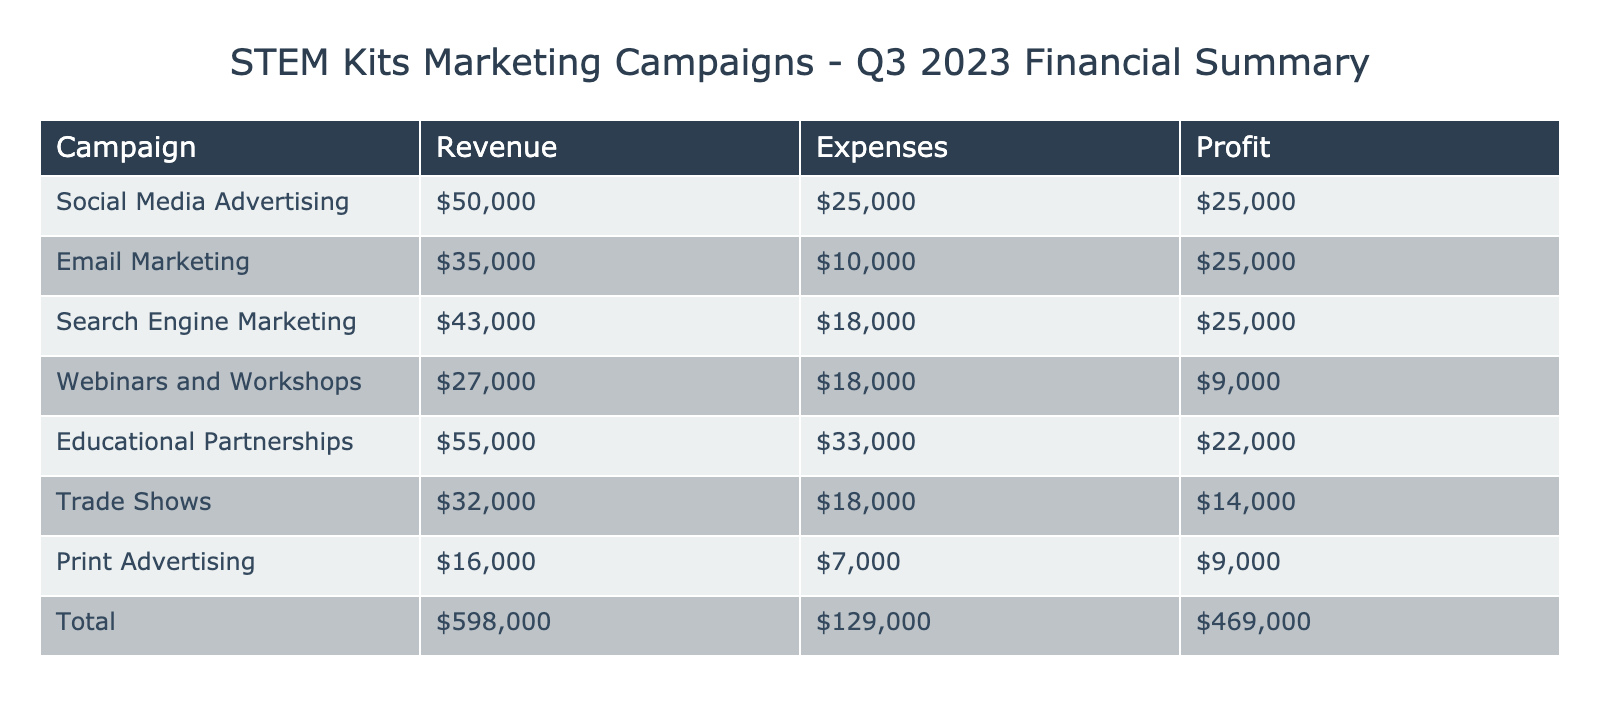What is the total revenue from all campaigns? To find the total revenue, sum the revenue amounts from each campaign: 50000 (Social Media) + 35000 (Email Marketing) + 43000 (Search Engine) + 27000 (Webinars) + 55000 (Partnerships) + 32000 (Trade Shows) + 16000 (Print) = 227000.
Answer: 227000 Which campaign had the highest profit? To determine the campaign with the highest profit, we calculate the profit for each campaign by subtracting total expenses from total revenue. The campaign with the highest profit is Educational Partnerships: 55000 (revenue) - 33000 (expenses) = 22000.
Answer: Educational Partnerships What is the total amount spent on Social Media Advertising? The total amount spent on Social Media Advertising is the sum of all expenses related to that campaign: 12000 (Facebook) + 8000 (Instagram) + 5000 (Twitter) = 25000.
Answer: 25000 Did Trade Shows have a higher expense than Search Engine Marketing? For Trade Shows, the total expense is 9000 (Booth) + 6000 (Travel) + 3000 (Marketing) = 18000. For Search Engine Marketing, the total expense is 15000 (Google) + 3000 (Bing) = 18000. Since the expenses are equal, the answer is no.
Answer: No What is the profit difference between Webinars and Workshops and Print Advertising? Calculate the profit of each campaign: Webinars has a revenue of 27000 and expenses of 18000, so profit is 9000. Print Advertising has a revenue of 16000 and expenses of 7000, so profit is 9000. The profit difference is 9000 - 9000 = 0.
Answer: 0 How much is spent on Email Marketing in total? The total amount spent on Email Marketing can be calculated by adding design and distribution costs: 4000 (Design) + 6000 (Distribution) = 10000.
Answer: 10000 What percentage of total revenue was derived from Educational Partnerships? First, we find the revenue from Educational Partnerships, which is 55000. The total revenue is 227000. The percentage is calculated as (55000 / 227000) * 100, which equals approximately 24.2%.
Answer: 24.2% Which type of advertising has the lowest expenses? The advertising with the lowest expenses is Print Advertising, with total expenses of 7000 (Magazine) + 2000 (Brochure) = 9000.
Answer: Print Advertising Is the combined revenue from Trade Shows and Email Marketing greater than the revenue from Webinars and Workshops? The revenue from Trade Shows is 32000 and from Email Marketing is 35000, combined they yield 32000 + 35000 = 67000. The revenue from Webinars and Workshops is 27000, which is lower than 67000. Thus, yes, the combined revenue is greater.
Answer: Yes 